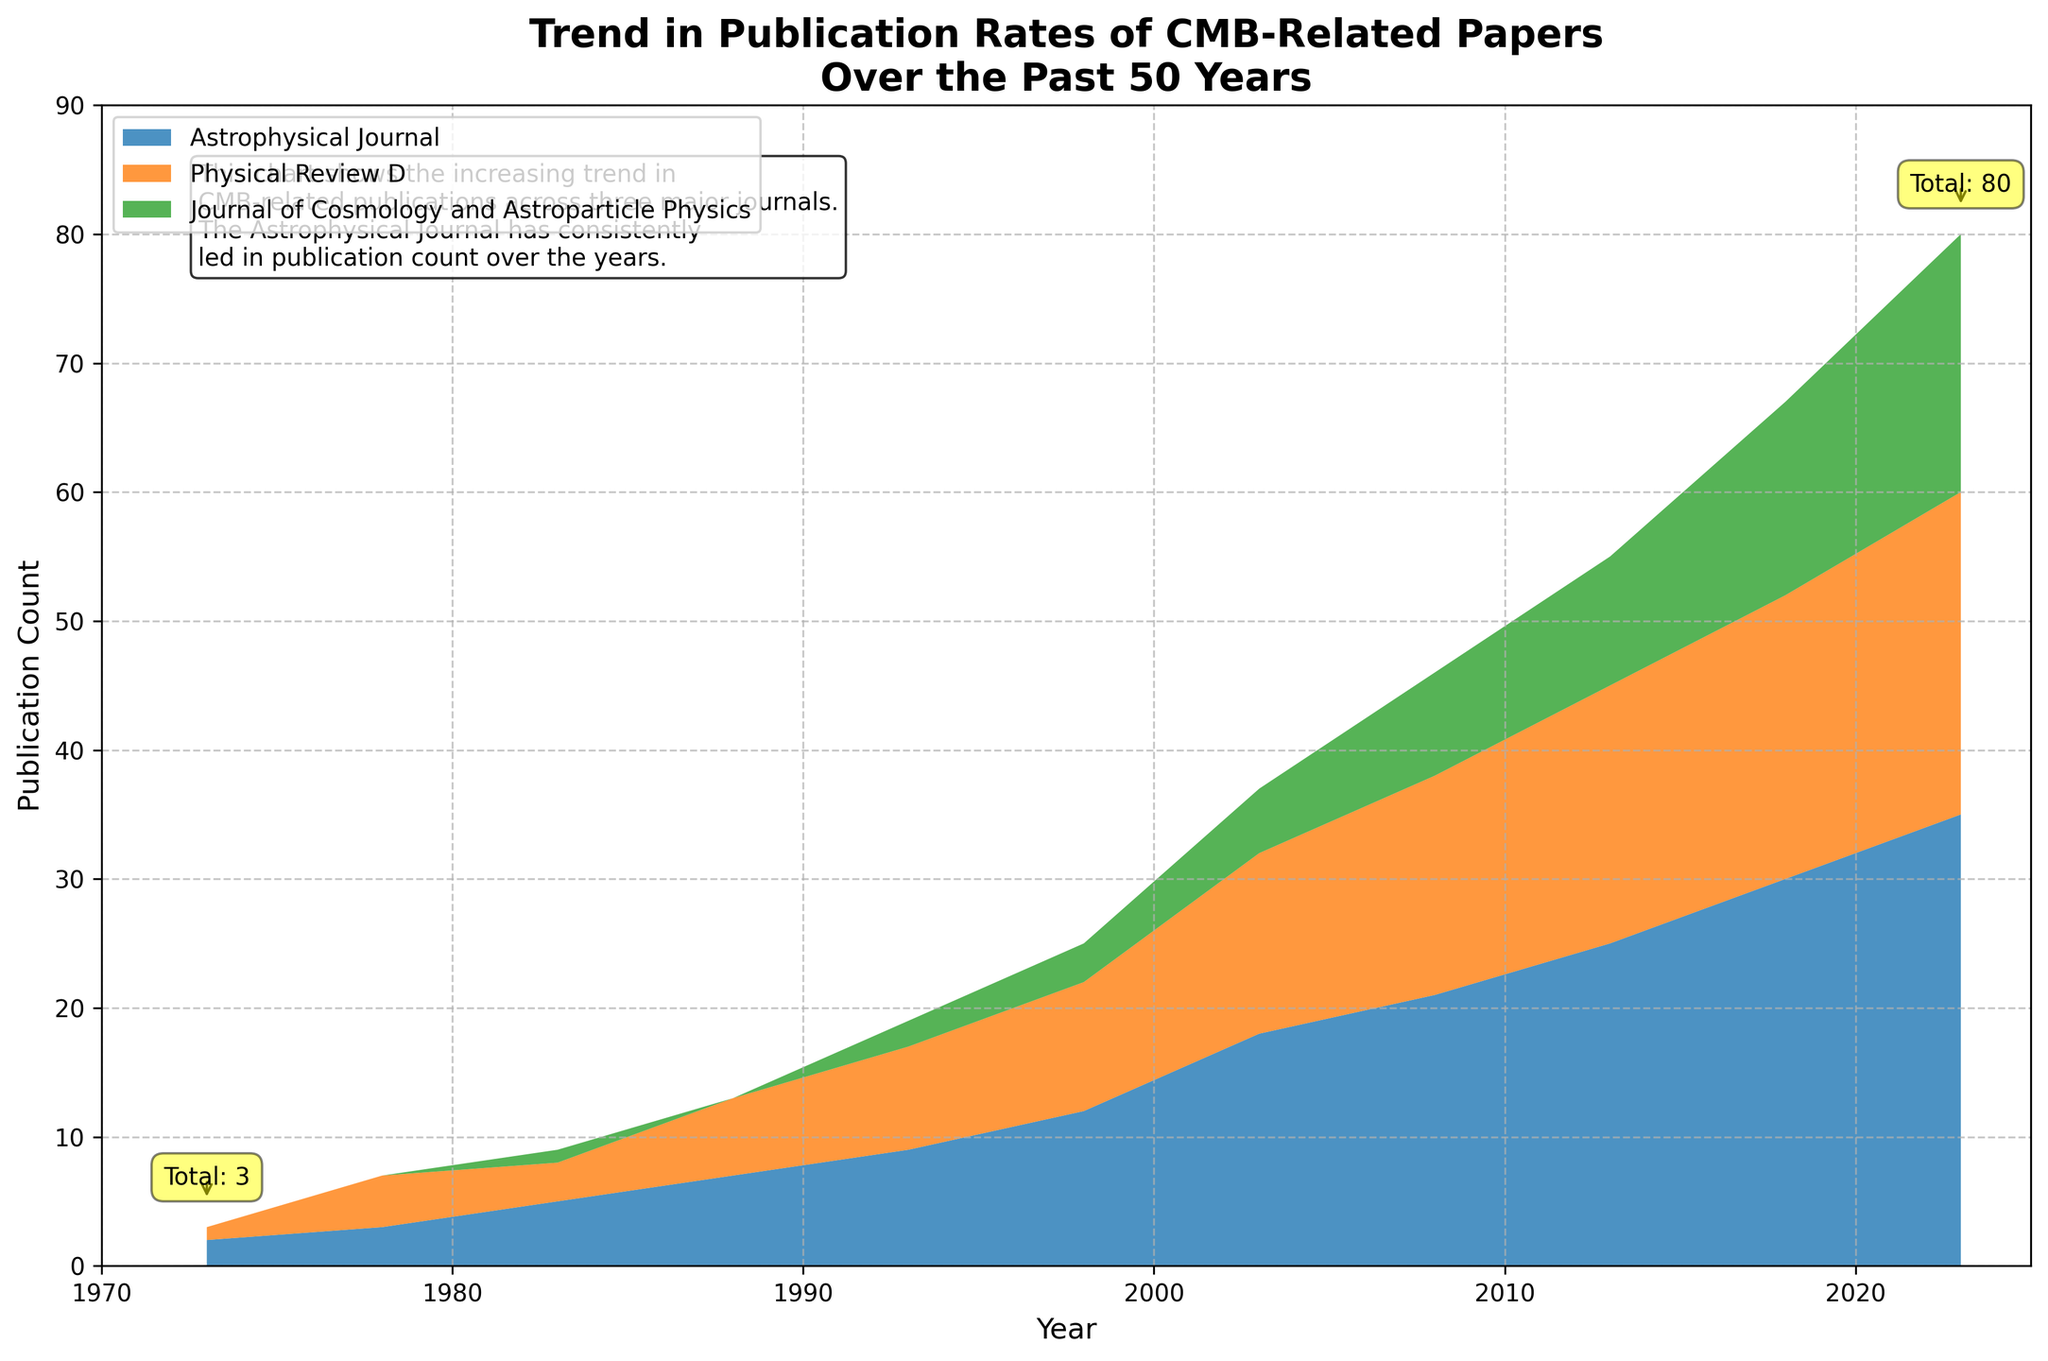What is the title of the figure? The title is usually at the top of the figure and it provides a summary of what the figure is about. This figure's title is placed prominently at the top in bold font.
Answer: Trend in Publication Rates of CMB-Related Papers Over the Past 50 Years What does the y-axis represent? The y-axis label is displayed vertically on the left side of the figure and it indicates what is being measured. In this figure, it represents the number of publications.
Answer: Publication Count Which journal consistently leads in publication count over the years? The legend on the figure helps identify which color corresponds to which journal. By examining the areas, the journal with the largest area consistently over time can be identified.
Answer: Astrophysical Journal How many publications in total were there in 1973? To find the total for 1973, sum the publication counts from all journals for that year. According to the annotations, the total is provided as a text box near the 1973 data points.
Answer: 3 How did the total publication counts in 2023 compare to 1973? Look at the figure annotations for 1973 and 2023, which indicate the total counts for each year. Subtract the total count of 1973 from that of 2023.
Answer: 77 (80 in 2023 - 3 in 1973) What trend is shown by the Journal of Cosmology and Astroparticle Physics over the years? Observe the specific area color for this journal in the area chart. Look at its progression from the left (earliest years) to the right (most recent years).
Answer: Increasing trend In which year did Physical Review D see a notable increase in publication counts? Examine the area corresponding to Physical Review D and identify any sharp increases. Notably, the trend appears to have a significant rise around 2003.
Answer: 2003 How many publications did the Journal of Cosmology and Astroparticle Physics have in 2008? Look at the point corresponding to 2008 for the specific color of the Journal of Cosmology and Astroparticle Physics to find the publication count.
Answer: 8 Approximately what percentage of the total publications in 2018 were from the Astrophysical Journal? First, sum the publication counts from all journals for 2018. Then, divide the count for the Astrophysical Journal by this total and multiply by 100 to find the percentage.
Answer: 50% (30/60 * 100) Which publication count displayed a more gradual increase over the years: Astrophysical Journal or Physical Review D? Compare the slopes of the areas for both journals. The Astrophysical Journal shows a more steady and gradual increase compared to Physical Review D's more rapid ascents and plateaus.
Answer: Astrophysical Journal 